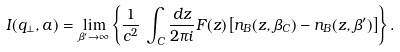Convert formula to latex. <formula><loc_0><loc_0><loc_500><loc_500>I ( q _ { \perp } , a ) = \lim _ { \beta ^ { \prime } \rightarrow \infty } \left \{ \frac { 1 } { c ^ { 2 } } \, \int _ { C } \frac { d z } { 2 \pi i } F ( z ) \left [ n _ { B } ( z , \beta _ { C } ) - n _ { B } ( z , \beta ^ { \prime } ) \right ] \right \} .</formula> 